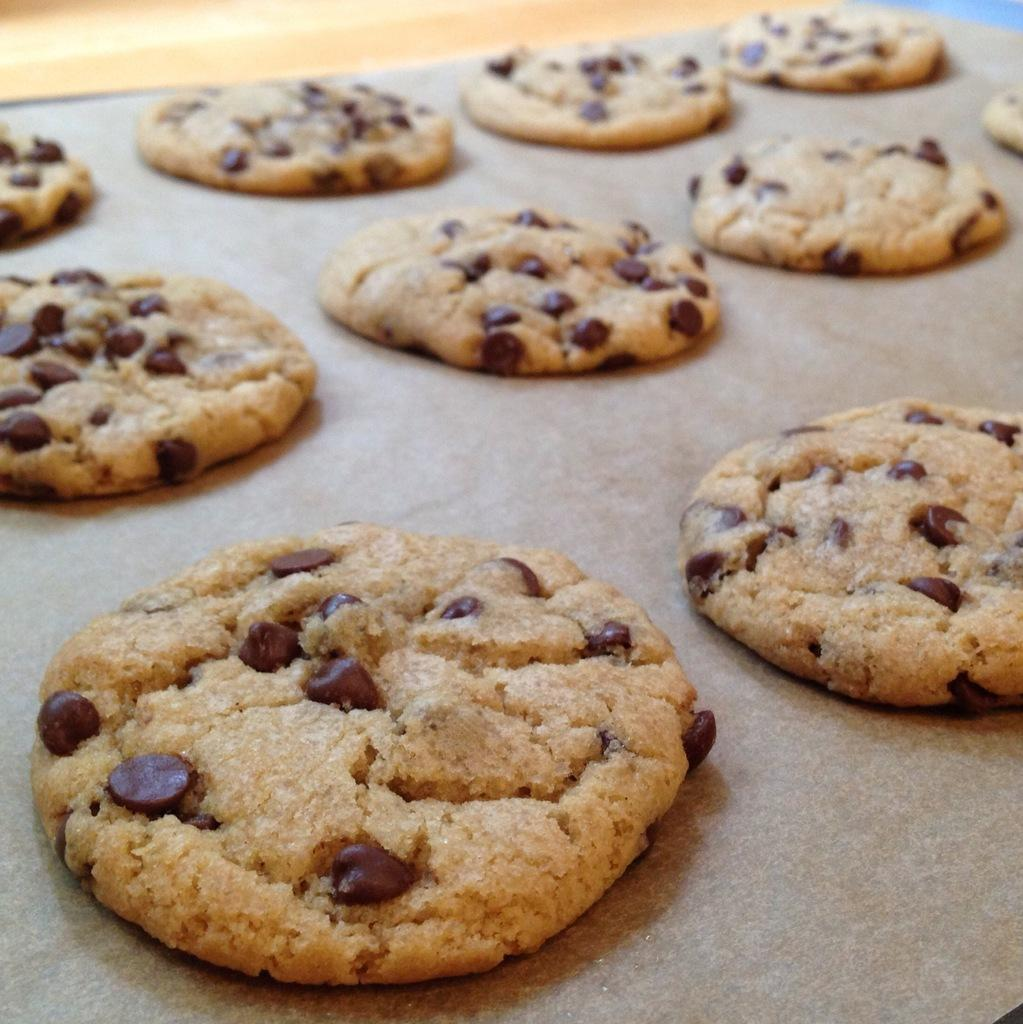What type of baked goods are in the image? There are baked choco cookies in the image. Where are the cookies located? The cookies are on a surface. What type of flame can be seen coming from the cookies in the image? There is no flame present in the image; it features baked choco cookies on a surface. What type of ball is being used to play with the cookies in the image? There is no ball or any indication of playing with the cookies in the image. 